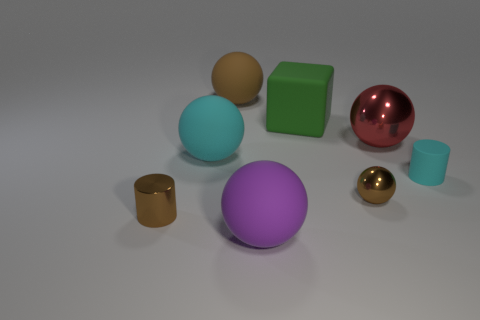Subtract 1 spheres. How many spheres are left? 4 Subtract all red balls. How many balls are left? 4 Subtract all cyan rubber spheres. How many spheres are left? 4 Add 1 red objects. How many objects exist? 9 Subtract all red cylinders. Subtract all purple spheres. How many cylinders are left? 2 Subtract all cylinders. How many objects are left? 6 Add 8 red metal balls. How many red metal balls exist? 9 Subtract 1 red spheres. How many objects are left? 7 Subtract all blocks. Subtract all big green matte blocks. How many objects are left? 6 Add 5 small cylinders. How many small cylinders are left? 7 